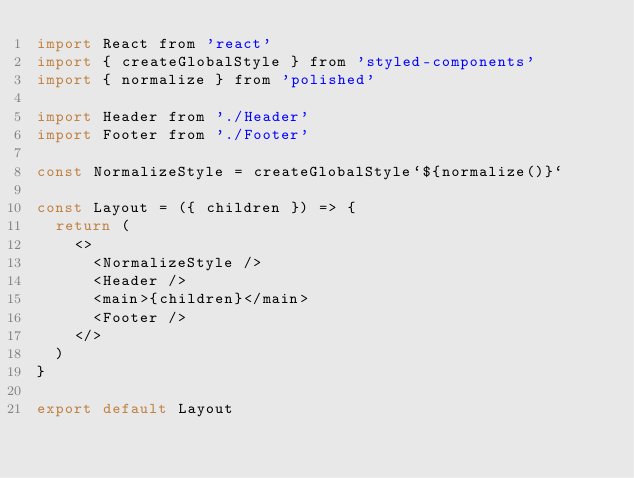<code> <loc_0><loc_0><loc_500><loc_500><_JavaScript_>import React from 'react'
import { createGlobalStyle } from 'styled-components'
import { normalize } from 'polished'

import Header from './Header'
import Footer from './Footer'

const NormalizeStyle = createGlobalStyle`${normalize()}`

const Layout = ({ children }) => {
  return (
    <>
      <NormalizeStyle />
      <Header />
      <main>{children}</main>
      <Footer />
    </>
  )
}

export default Layout
</code> 